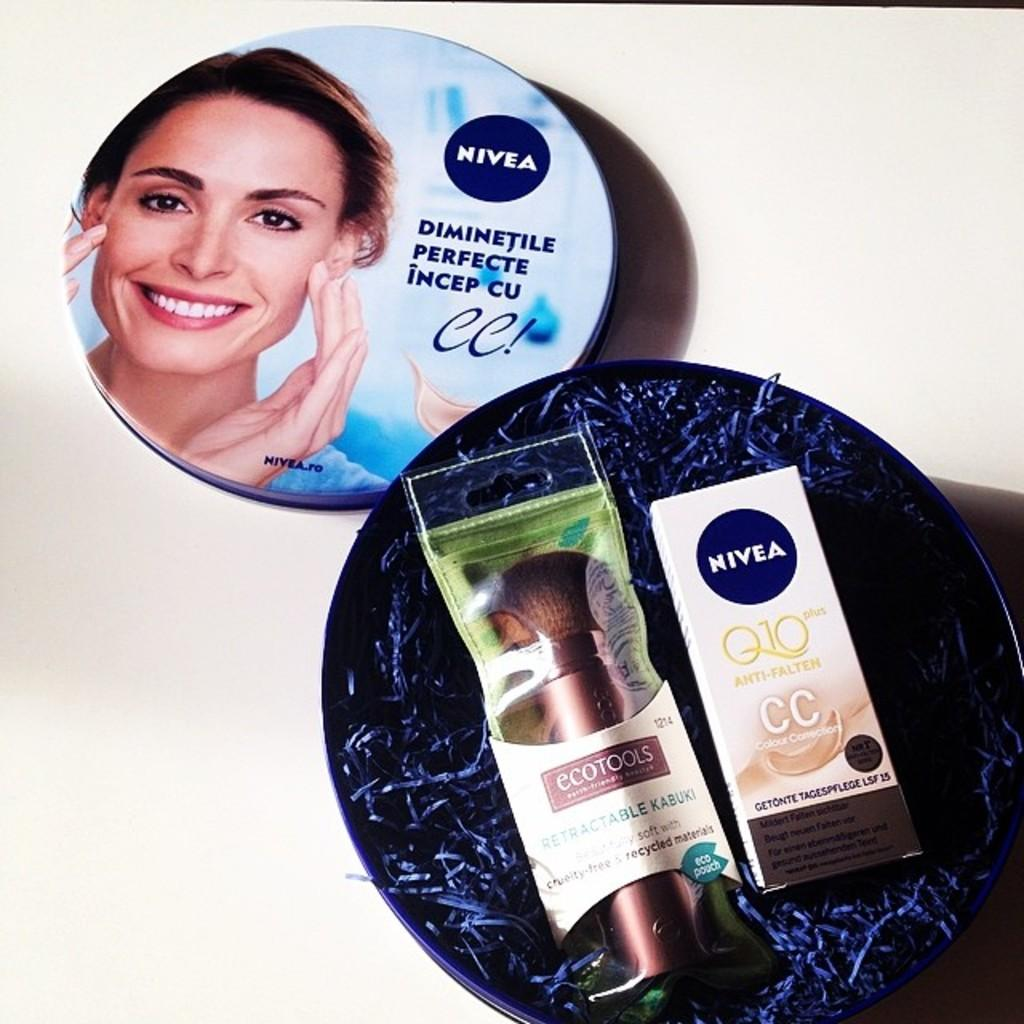<image>
Relay a brief, clear account of the picture shown. A collection of beauty products made from Nivea 